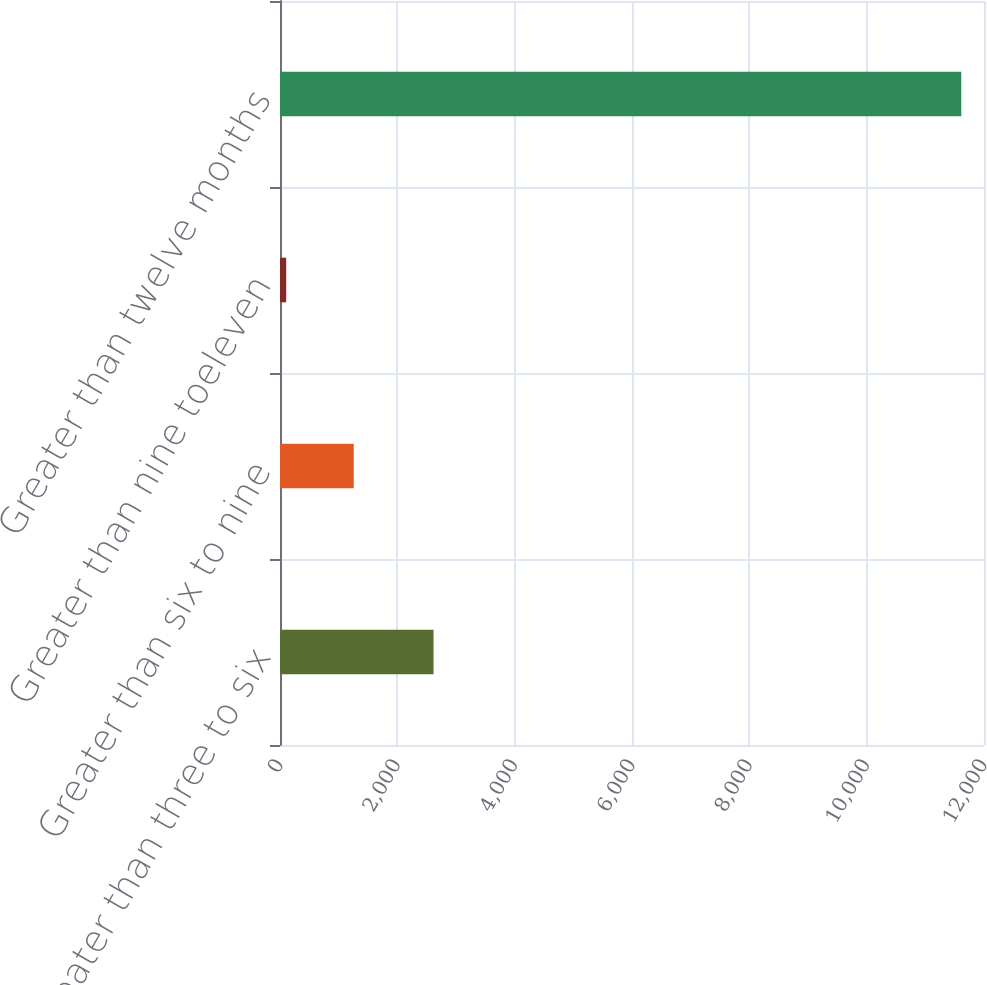<chart> <loc_0><loc_0><loc_500><loc_500><bar_chart><fcel>Greater than three to six<fcel>Greater than six to nine<fcel>Greater than nine toeleven<fcel>Greater than twelve months<nl><fcel>2617<fcel>1256.7<fcel>106<fcel>11613<nl></chart> 